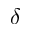Convert formula to latex. <formula><loc_0><loc_0><loc_500><loc_500>\delta</formula> 